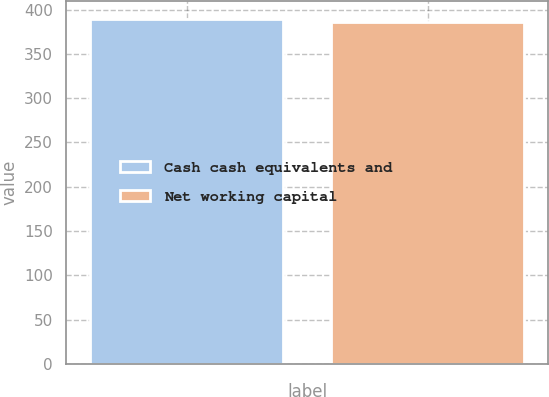Convert chart to OTSL. <chart><loc_0><loc_0><loc_500><loc_500><bar_chart><fcel>Cash cash equivalents and<fcel>Net working capital<nl><fcel>389.6<fcel>385.7<nl></chart> 